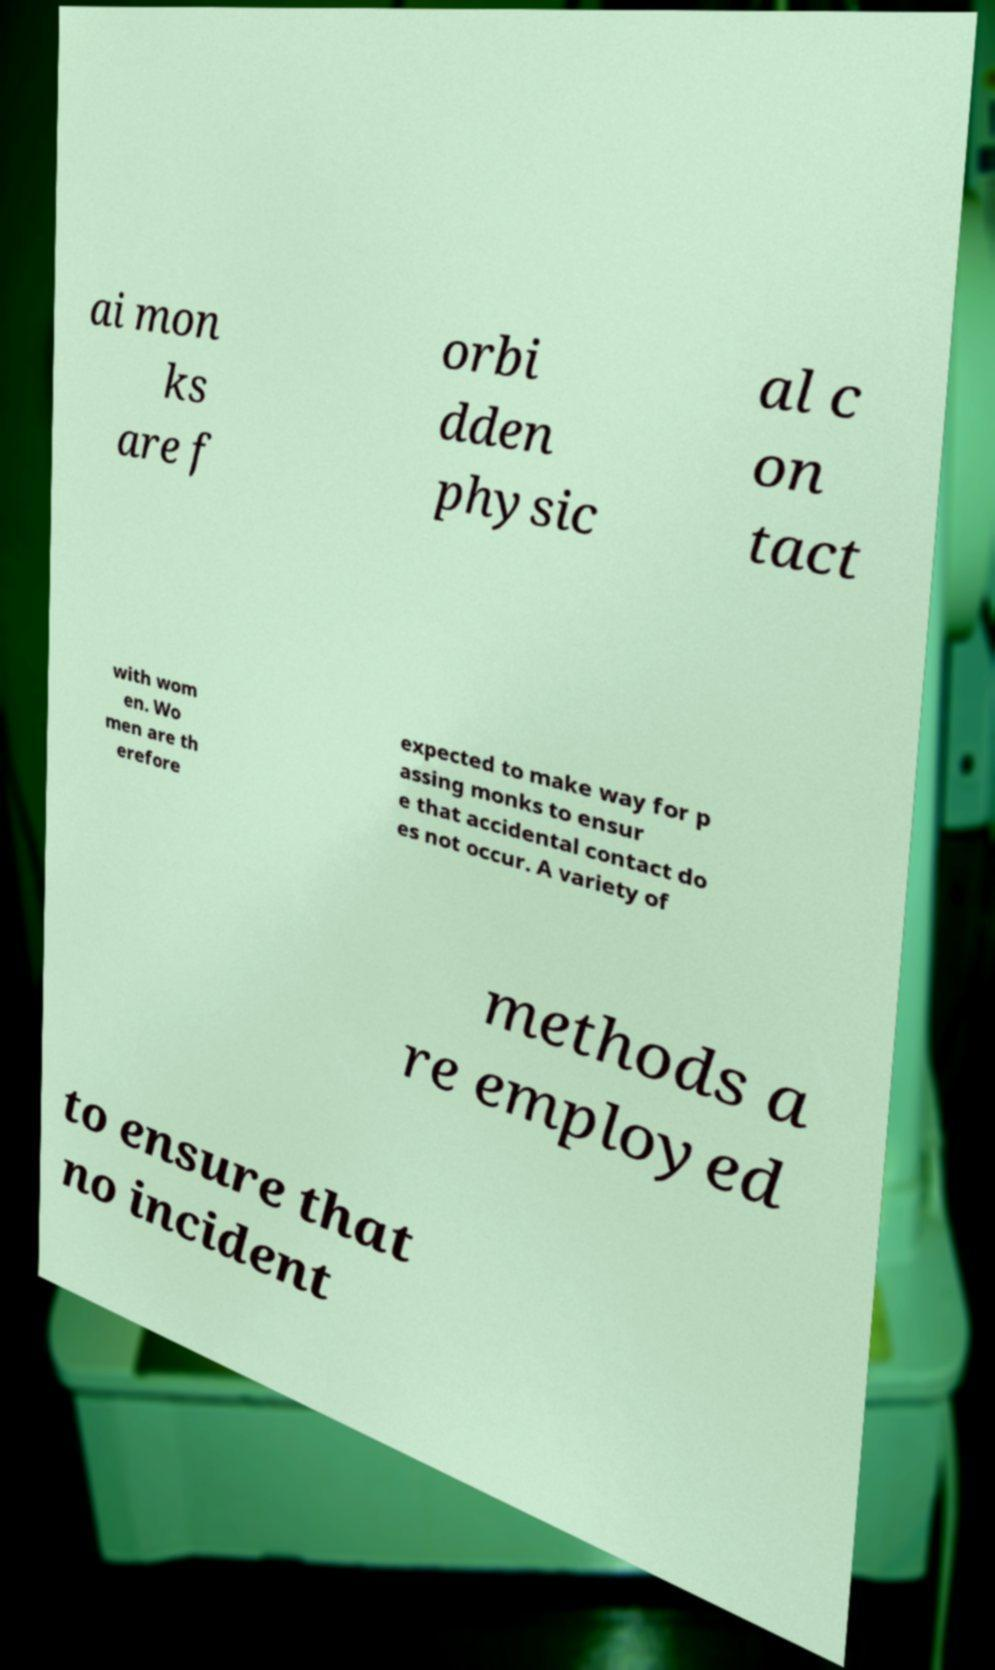I need the written content from this picture converted into text. Can you do that? ai mon ks are f orbi dden physic al c on tact with wom en. Wo men are th erefore expected to make way for p assing monks to ensur e that accidental contact do es not occur. A variety of methods a re employed to ensure that no incident 